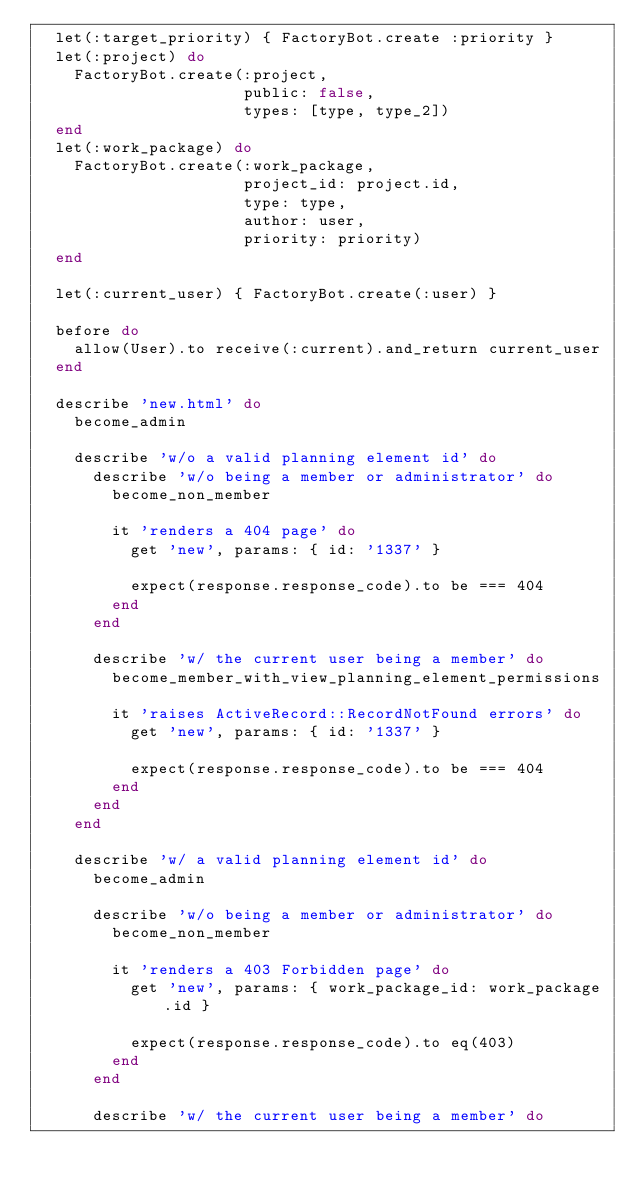Convert code to text. <code><loc_0><loc_0><loc_500><loc_500><_Ruby_>  let(:target_priority) { FactoryBot.create :priority }
  let(:project) do
    FactoryBot.create(:project,
                      public: false,
                      types: [type, type_2])
  end
  let(:work_package) do
    FactoryBot.create(:work_package,
                      project_id: project.id,
                      type: type,
                      author: user,
                      priority: priority)
  end

  let(:current_user) { FactoryBot.create(:user) }

  before do
    allow(User).to receive(:current).and_return current_user
  end

  describe 'new.html' do
    become_admin

    describe 'w/o a valid planning element id' do
      describe 'w/o being a member or administrator' do
        become_non_member

        it 'renders a 404 page' do
          get 'new', params: { id: '1337' }

          expect(response.response_code).to be === 404
        end
      end

      describe 'w/ the current user being a member' do
        become_member_with_view_planning_element_permissions

        it 'raises ActiveRecord::RecordNotFound errors' do
          get 'new', params: { id: '1337' }

          expect(response.response_code).to be === 404
        end
      end
    end

    describe 'w/ a valid planning element id' do
      become_admin

      describe 'w/o being a member or administrator' do
        become_non_member

        it 'renders a 403 Forbidden page' do
          get 'new', params: { work_package_id: work_package.id }

          expect(response.response_code).to eq(403)
        end
      end

      describe 'w/ the current user being a member' do</code> 